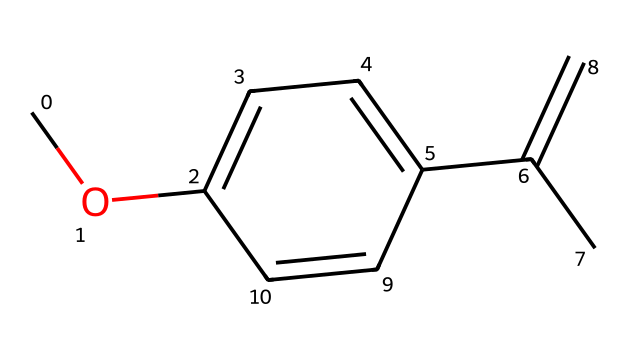What is the main functional group in this chemical structure? The chemical structure contains an ether functional group, characterized by an oxygen atom connected to two carbon atoms. This is identified in the structural representation where the oxygen (O) is connected to two hydrocarbon parts.
Answer: ether How many carbon atoms are in the molecular structure of eucalyptus oil ether? By analyzing the SMILES representation, we count all the carbon atoms present, which are indicated by the letter 'C' in the structure. There are a total of 10 carbon atoms upon careful identification throughout the structure.
Answer: 10 What type of bonding is primarily present in eucalyptus oil ether? The chemical structure indicates the presence of single covalent bonds between the carbon atoms and between carbon and oxygen. In the representation, we can observe that most connections are straightforward 'C-C' and 'C-O' without any double or triple bonds in the ether portion.
Answer: single bonds What does the structure suggest about the volatility of eucalyptus oil ether? Examination of the structure shows a relatively simple arrangement with a low molecular weight, which typically indicates higher volatility. The linear and branched structure also contributes to easy evaporation, suggesting significant volatility.
Answer: high Which part of the structure contributes to its natural repellent properties? The particular arrangement of carbon atoms and the presence of the ether functional group are essential for the compound's interactions with biological systems (e.g., insects). The hydrophobic character of the molecule plays a role in its ability to repel certain pests.
Answer: carbon and ether group Does this chemical have any potential for hydrogen bonding? Despite the presence of an oxygen atom, the structure lacks hydroxyl (OH) or amino (NH) groups that typically facilitate hydrogen bonding. Instead, the ether function provides a different type of interaction that does not significantly lead to hydrogen bonding.
Answer: no 